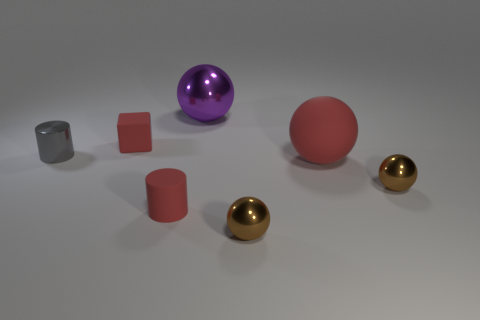Is the object in front of the red matte cylinder made of the same material as the large purple object?
Your response must be concise. Yes. There is a small object that is both behind the large red rubber sphere and right of the gray thing; what is its material?
Provide a succinct answer. Rubber. What color is the ball that is to the right of the big object in front of the large purple metal object?
Offer a terse response. Brown. There is a small red thing that is the same shape as the gray shiny object; what is it made of?
Make the answer very short. Rubber. There is a small metal thing on the left side of the metal object behind the rubber thing behind the large red sphere; what is its color?
Your answer should be very brief. Gray. How many objects are tiny purple shiny spheres or purple objects?
Provide a short and direct response. 1. What number of large purple shiny things have the same shape as the gray shiny object?
Provide a short and direct response. 0. Do the block and the small brown ball behind the tiny matte cylinder have the same material?
Ensure brevity in your answer.  No. There is a purple ball that is made of the same material as the tiny gray cylinder; what size is it?
Your response must be concise. Large. There is a rubber thing that is on the right side of the purple ball; what is its size?
Make the answer very short. Large. 